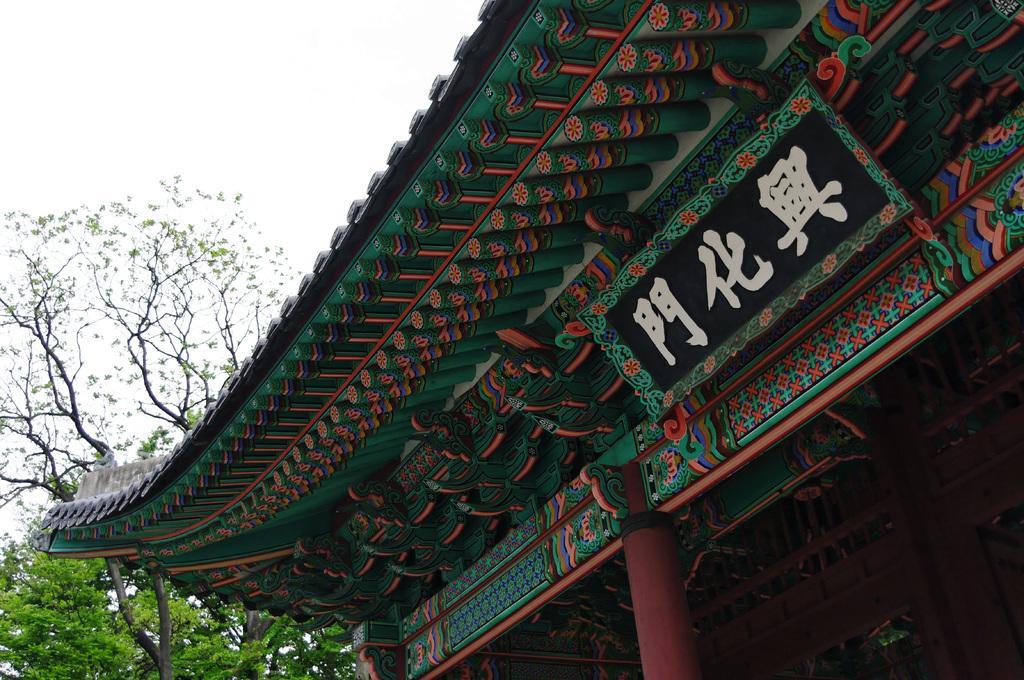How would you summarize this image in a sentence or two? In this picture we can see some text on an ancient architecture. There are a few trees visible on the left side. 